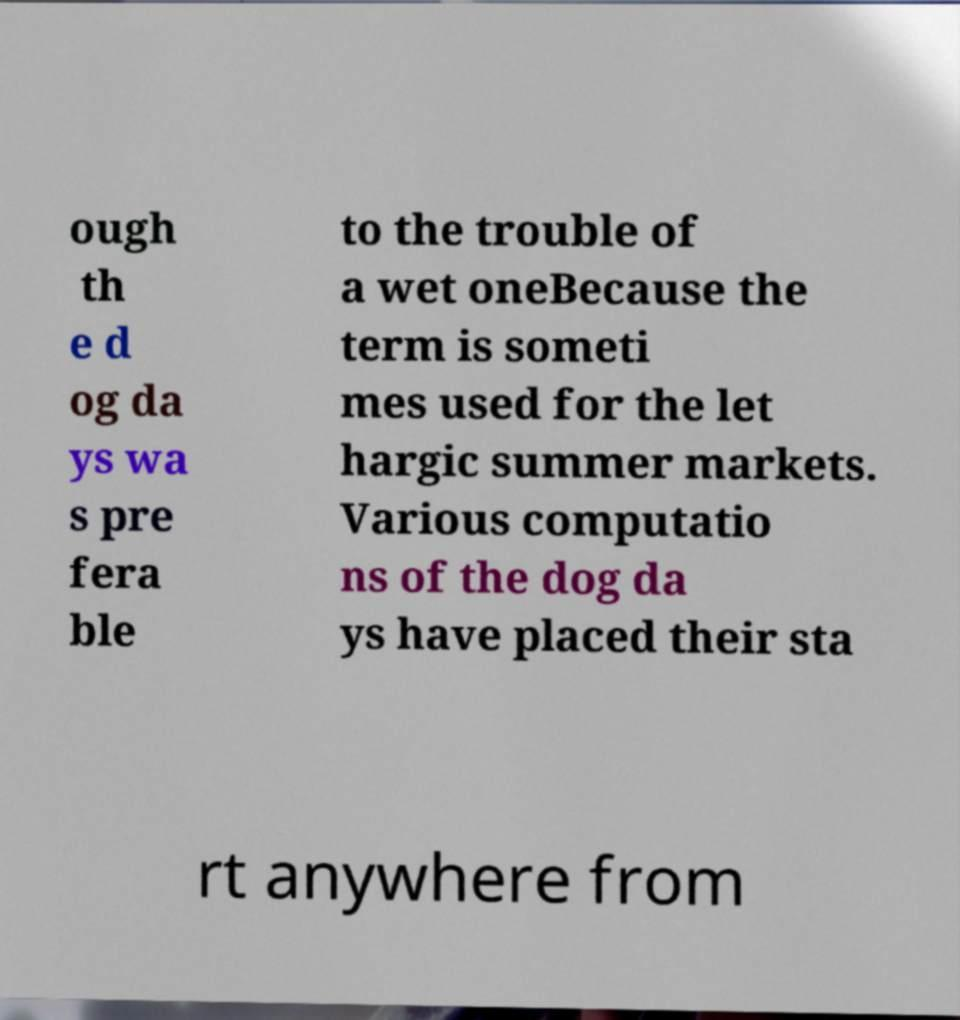Please read and relay the text visible in this image. What does it say? ough th e d og da ys wa s pre fera ble to the trouble of a wet oneBecause the term is someti mes used for the let hargic summer markets. Various computatio ns of the dog da ys have placed their sta rt anywhere from 